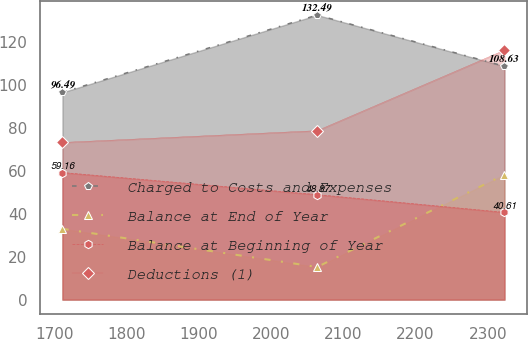Convert chart to OTSL. <chart><loc_0><loc_0><loc_500><loc_500><line_chart><ecel><fcel>Charged to Costs and Expenses<fcel>Balance at End of Year<fcel>Balance at Beginning of Year<fcel>Deductions (1)<nl><fcel>1711.22<fcel>96.49<fcel>32.97<fcel>59.16<fcel>73.17<nl><fcel>2063.88<fcel>132.49<fcel>15.18<fcel>48.87<fcel>78.66<nl><fcel>2323.04<fcel>108.63<fcel>58.2<fcel>40.61<fcel>116.11<nl></chart> 